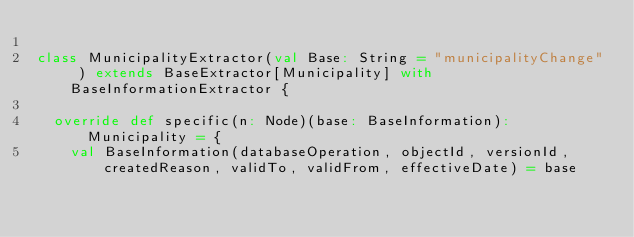<code> <loc_0><loc_0><loc_500><loc_500><_Scala_>
class MunicipalityExtractor(val Base: String = "municipalityChange" ) extends BaseExtractor[Municipality] with BaseInformationExtractor {

  override def specific(n: Node)(base: BaseInformation): Municipality = {
    val BaseInformation(databaseOperation, objectId, versionId, createdReason, validTo, validFrom, effectiveDate) = base
</code> 